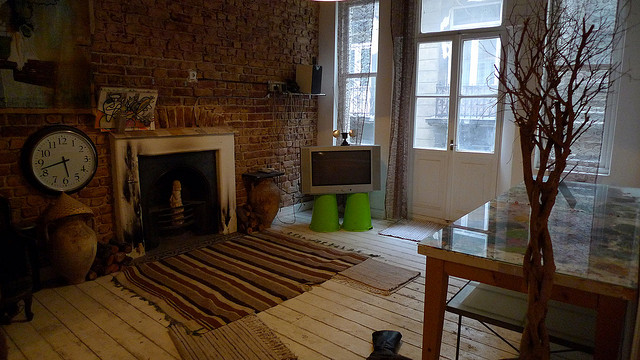Identify and read out the text in this image. 1 12 II 10 5 3 9 8 7 6 4 2 